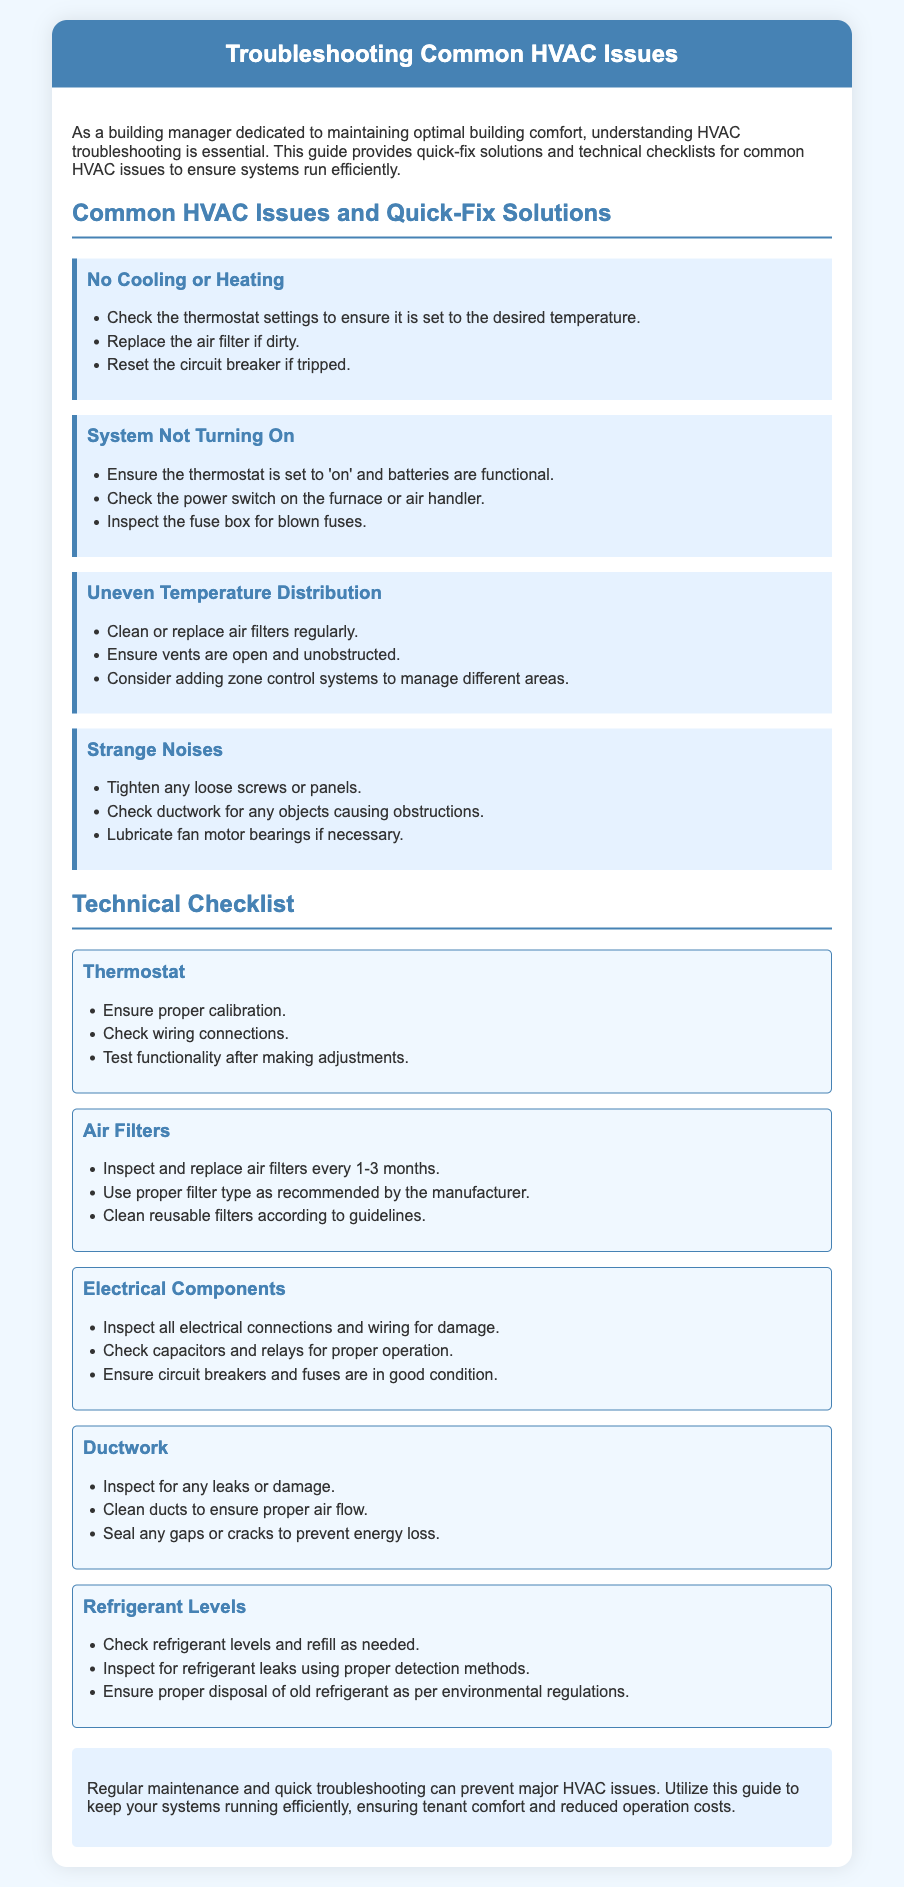What is the title of the document? The title is provided in the header section of the document.
Answer: Troubleshooting Common HVAC Issues How many common HVAC issues are listed? The document lists a total of four common HVAC issues in separate sections.
Answer: Four What should you do if the system is not turning on? There are specific steps listed under the "System Not Turning On" issue.
Answer: Ensure the thermostat is set to 'on' and batteries are functional How often should air filters be replaced? The technical checklist specifies a recommended replacement frequency for air filters.
Answer: Every 1-3 months What is the main purpose of this guide? The main purpose is described in the introductory paragraph.
Answer: To ensure systems run efficiently What additional system is suggested for managing different areas? The guide provides a solution for uneven temperature distribution.
Answer: Zone control systems What color is the header background? The header background color is mentioned in the style section.
Answer: #4682b4 What should be checked for blown fuses? This is part of the checklist for the "System Not Turning On" issue.
Answer: Fuse box 